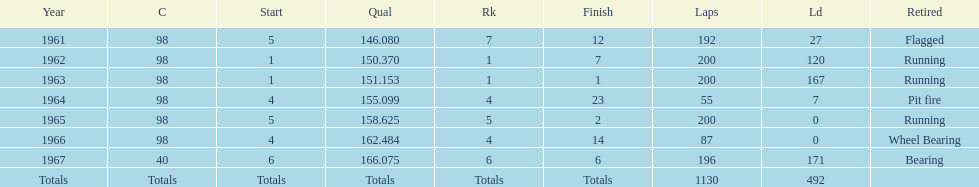When did jones secure a number 5 start at the indy 500 before 1965? 1961. 